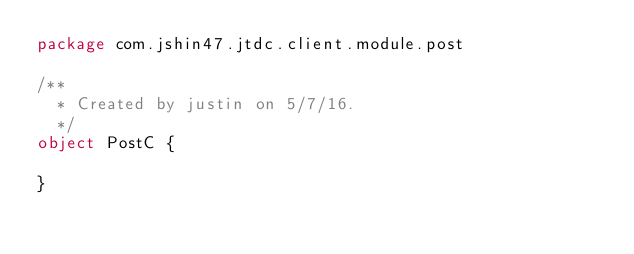Convert code to text. <code><loc_0><loc_0><loc_500><loc_500><_Scala_>package com.jshin47.jtdc.client.module.post

/**
  * Created by justin on 5/7/16.
  */
object PostC {

}
</code> 